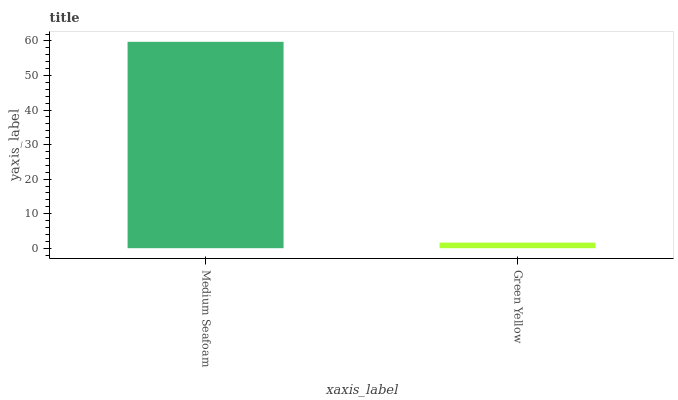Is Green Yellow the minimum?
Answer yes or no. Yes. Is Medium Seafoam the maximum?
Answer yes or no. Yes. Is Green Yellow the maximum?
Answer yes or no. No. Is Medium Seafoam greater than Green Yellow?
Answer yes or no. Yes. Is Green Yellow less than Medium Seafoam?
Answer yes or no. Yes. Is Green Yellow greater than Medium Seafoam?
Answer yes or no. No. Is Medium Seafoam less than Green Yellow?
Answer yes or no. No. Is Medium Seafoam the high median?
Answer yes or no. Yes. Is Green Yellow the low median?
Answer yes or no. Yes. Is Green Yellow the high median?
Answer yes or no. No. Is Medium Seafoam the low median?
Answer yes or no. No. 